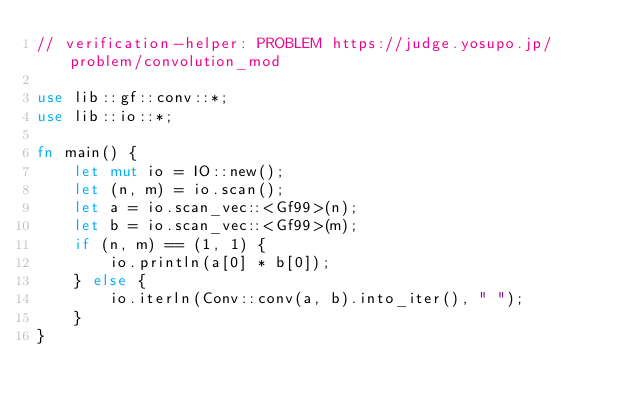Convert code to text. <code><loc_0><loc_0><loc_500><loc_500><_Rust_>// verification-helper: PROBLEM https://judge.yosupo.jp/problem/convolution_mod

use lib::gf::conv::*;
use lib::io::*;

fn main() {
    let mut io = IO::new();
    let (n, m) = io.scan();
    let a = io.scan_vec::<Gf99>(n);
    let b = io.scan_vec::<Gf99>(m);
    if (n, m) == (1, 1) {
        io.println(a[0] * b[0]);
    } else {
        io.iterln(Conv::conv(a, b).into_iter(), " ");
    }
}
</code> 